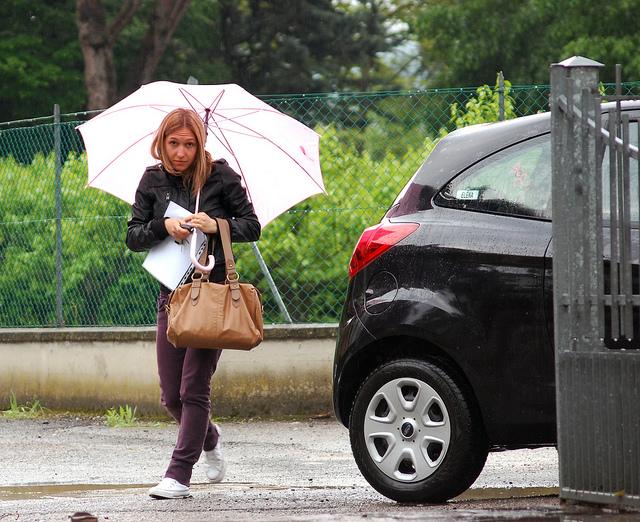What is the woman holding in her right hand?
Short answer required. Book. What color is the cat?
Be succinct. Black. What is the umbrella shading the woman from?
Give a very brief answer. Rain. Is the woman wet?
Give a very brief answer. No. 